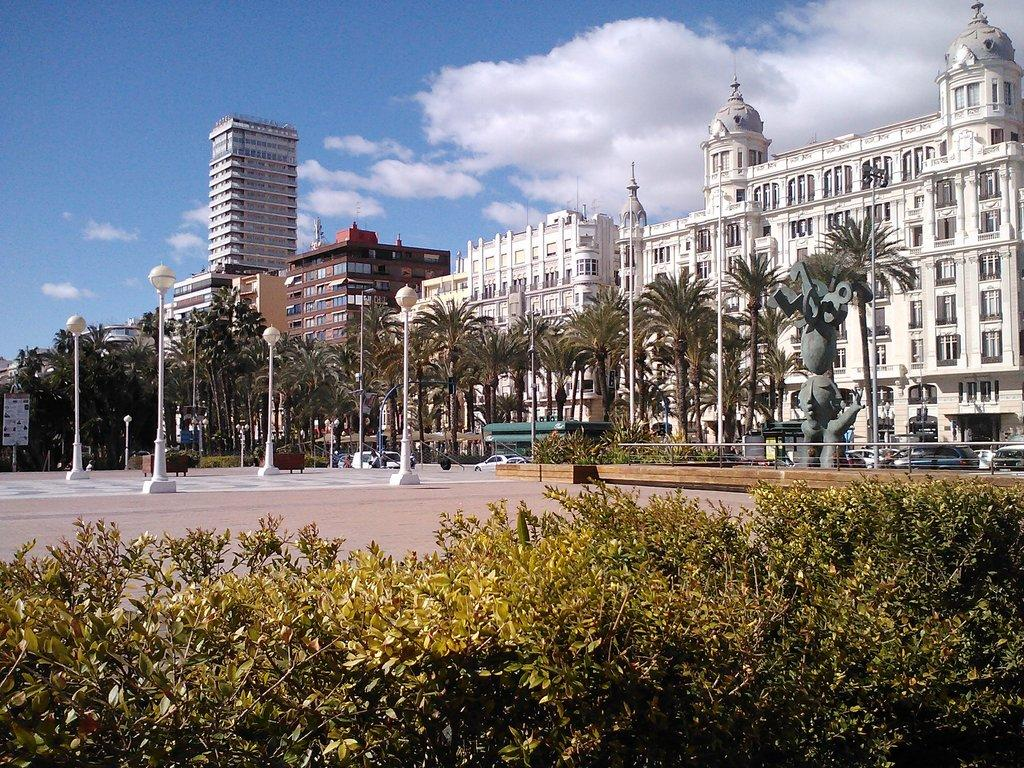What type of vegetation can be seen in the image? There are trees and plants in the image. What structures are present in the image? There are poles, a board, and walls in the image. What is the condition of the sky in the background of the image? The sky is cloudy in the background of the image. What type of pathway is visible in the image? There is a walkway in the image. What can be seen in the background of the image? There are vehicles, buildings, walls, windows, and a cloudy sky in the background of the image. Can you tell me how many rabbits are playing baseball on the walkway in the image? There are no rabbits or baseball games present in the image; it features trees, poles, lights, a board, plants, a walkway, vehicles, buildings, walls, windows, and a cloudy sky. 